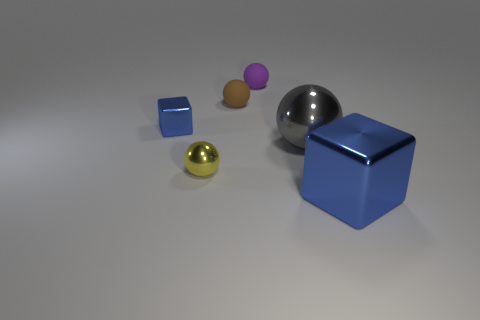Add 3 tiny purple spheres. How many objects exist? 9 Subtract all green balls. Subtract all gray cubes. How many balls are left? 4 Subtract all balls. How many objects are left? 2 Add 3 large red cylinders. How many large red cylinders exist? 3 Subtract 0 yellow cubes. How many objects are left? 6 Subtract all large cyan blocks. Subtract all purple spheres. How many objects are left? 5 Add 4 yellow metal balls. How many yellow metal balls are left? 5 